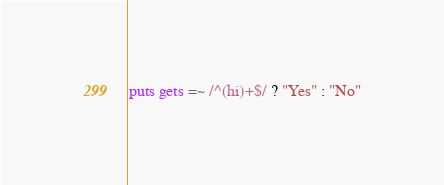Convert code to text. <code><loc_0><loc_0><loc_500><loc_500><_Ruby_>puts gets =~ /^(hi)+$/ ? "Yes" : "No"
</code> 